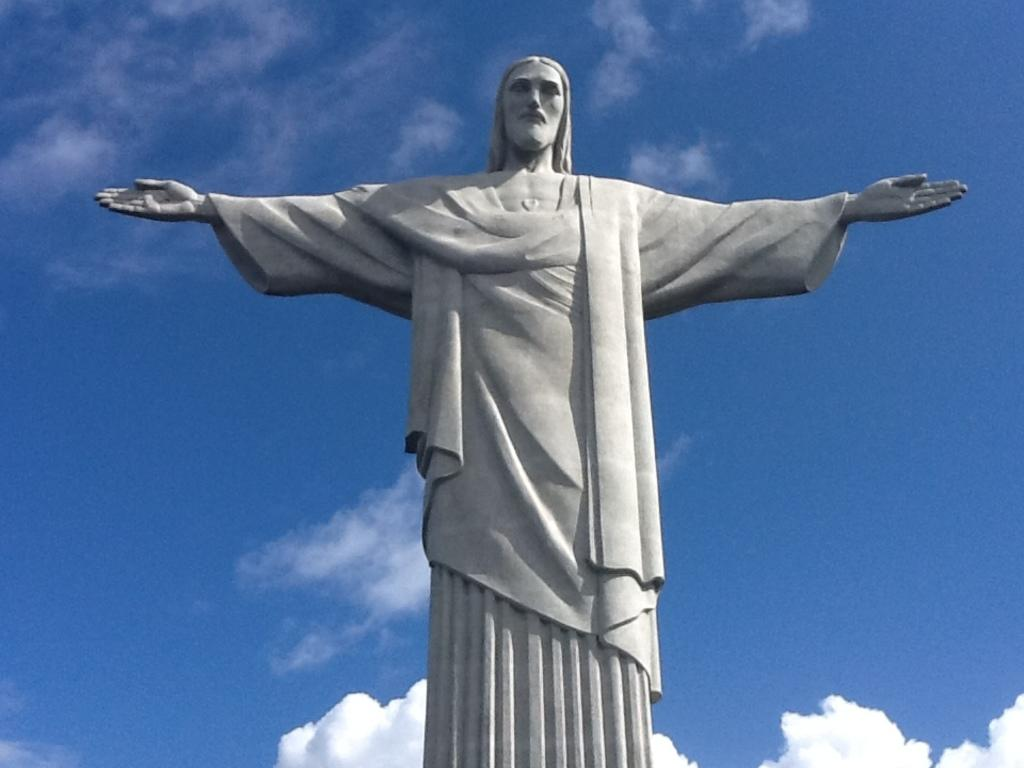What is the main subject of the image? The main subject of the image is a statue of a person. What can be seen in the background of the image? The background of the image includes sky with clouds. How many cows are grazing in the background of the image? There are no cows present in the image; the background only includes sky with clouds. What type of breakfast is being served on the statue's head in the image? There is no breakfast depicted in the image; it features a statue of a person with no additional objects or food. 